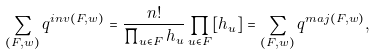Convert formula to latex. <formula><loc_0><loc_0><loc_500><loc_500>\sum _ { ( F , w ) } q ^ { i n v ( F , w ) } = \frac { n ! } { \prod _ { u \in F } h _ { u } } \prod _ { u \in F } [ h _ { u } ] = \sum _ { ( F , w ) } q ^ { m a j ( F , w ) } ,</formula> 